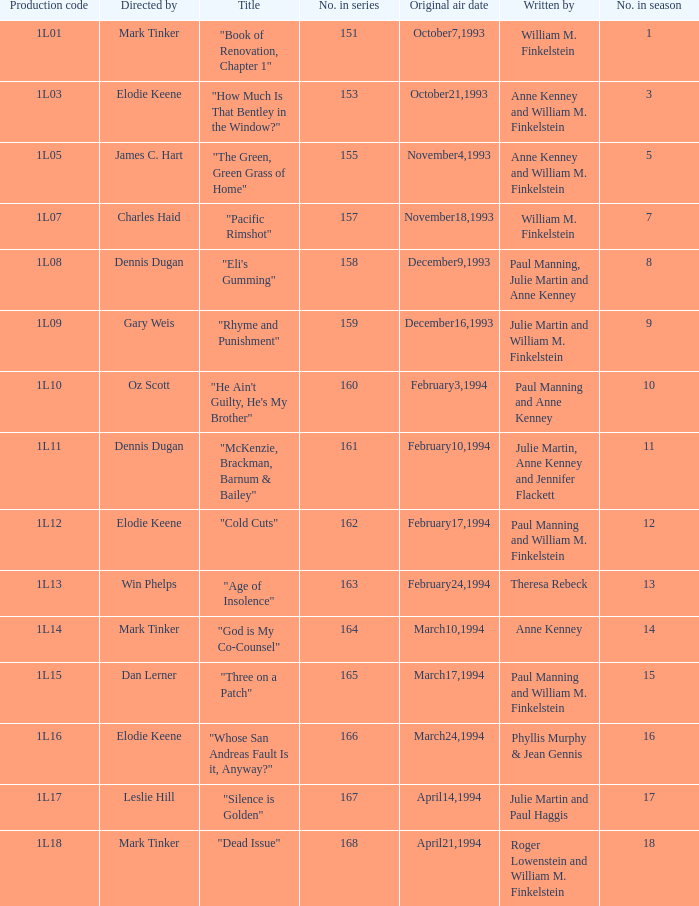Name the production code for theresa rebeck 1L13. 